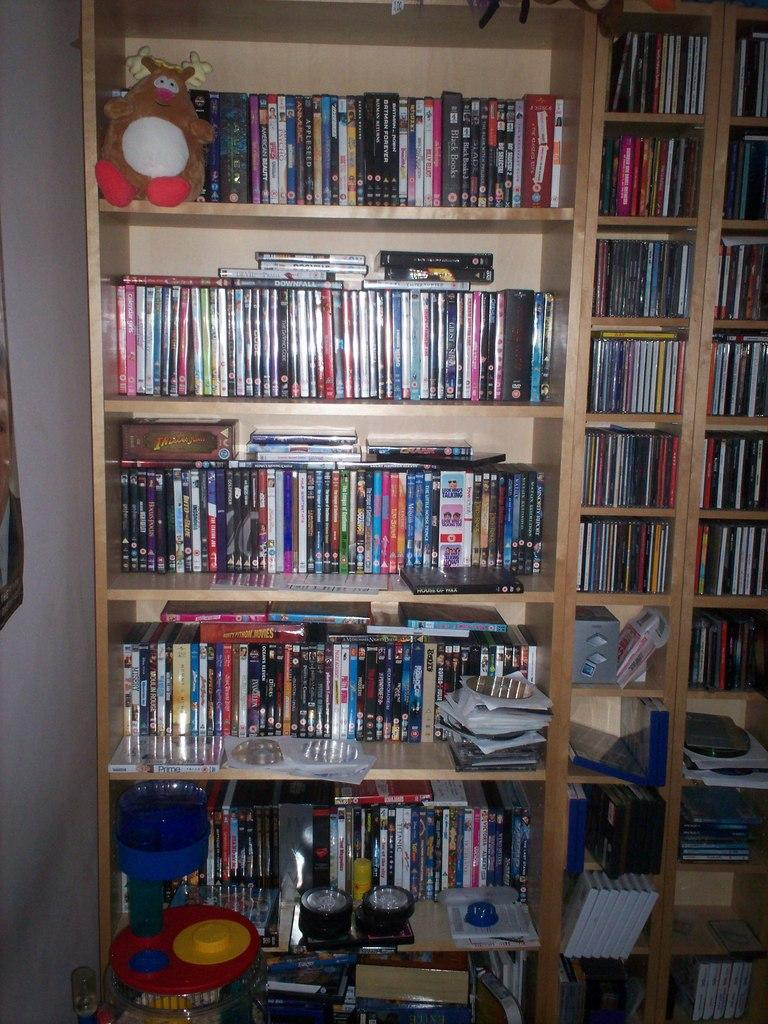What type of items can be seen in the image? There are books, toys, and CDs in the image. Where are the books and CDs located? The books and CDs are in the book shelves. What other objects can be found in the book shelves? There are toys in the book shelves. What type of rose can be seen growing in the image? There is no rose present in the image; it features books, toys, and CDs in book shelves. 